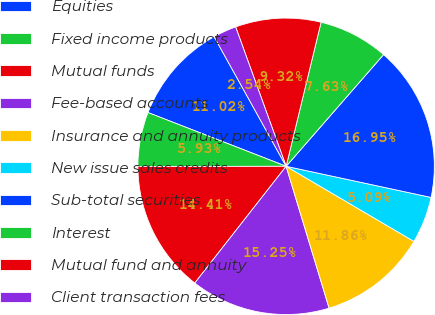<chart> <loc_0><loc_0><loc_500><loc_500><pie_chart><fcel>Equities<fcel>Fixed income products<fcel>Mutual funds<fcel>Fee-based accounts<fcel>Insurance and annuity products<fcel>New issue sales credits<fcel>Sub-total securities<fcel>Interest<fcel>Mutual fund and annuity<fcel>Client transaction fees<nl><fcel>11.02%<fcel>5.93%<fcel>14.41%<fcel>15.25%<fcel>11.86%<fcel>5.09%<fcel>16.95%<fcel>7.63%<fcel>9.32%<fcel>2.54%<nl></chart> 